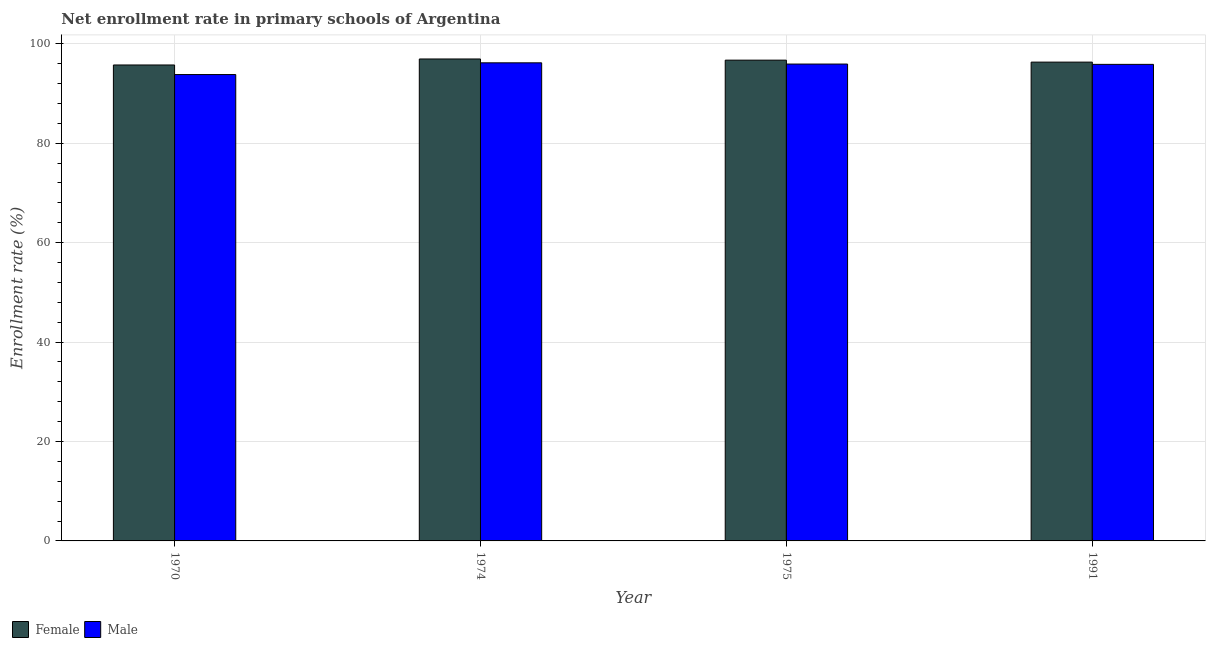How many different coloured bars are there?
Your answer should be compact. 2. Are the number of bars on each tick of the X-axis equal?
Provide a short and direct response. Yes. How many bars are there on the 1st tick from the left?
Provide a succinct answer. 2. In how many cases, is the number of bars for a given year not equal to the number of legend labels?
Your response must be concise. 0. What is the enrollment rate of male students in 1974?
Give a very brief answer. 96.17. Across all years, what is the maximum enrollment rate of female students?
Offer a terse response. 96.94. Across all years, what is the minimum enrollment rate of male students?
Ensure brevity in your answer.  93.81. In which year was the enrollment rate of female students maximum?
Provide a succinct answer. 1974. In which year was the enrollment rate of female students minimum?
Provide a short and direct response. 1970. What is the total enrollment rate of male students in the graph?
Provide a succinct answer. 381.76. What is the difference between the enrollment rate of female students in 1970 and that in 1974?
Make the answer very short. -1.21. What is the difference between the enrollment rate of female students in 1991 and the enrollment rate of male students in 1970?
Provide a succinct answer. 0.57. What is the average enrollment rate of female students per year?
Ensure brevity in your answer.  96.42. In how many years, is the enrollment rate of female students greater than 44 %?
Offer a very short reply. 4. What is the ratio of the enrollment rate of male students in 1970 to that in 1975?
Ensure brevity in your answer.  0.98. What is the difference between the highest and the second highest enrollment rate of male students?
Ensure brevity in your answer.  0.25. What is the difference between the highest and the lowest enrollment rate of female students?
Offer a terse response. 1.21. Is the sum of the enrollment rate of female students in 1975 and 1991 greater than the maximum enrollment rate of male students across all years?
Provide a short and direct response. Yes. What does the 2nd bar from the left in 1974 represents?
Your response must be concise. Male. Are all the bars in the graph horizontal?
Your answer should be very brief. No. Does the graph contain any zero values?
Make the answer very short. No. How many legend labels are there?
Provide a short and direct response. 2. What is the title of the graph?
Offer a very short reply. Net enrollment rate in primary schools of Argentina. What is the label or title of the Y-axis?
Your answer should be compact. Enrollment rate (%). What is the Enrollment rate (%) of Female in 1970?
Your answer should be compact. 95.74. What is the Enrollment rate (%) of Male in 1970?
Keep it short and to the point. 93.81. What is the Enrollment rate (%) in Female in 1974?
Provide a succinct answer. 96.94. What is the Enrollment rate (%) in Male in 1974?
Your answer should be very brief. 96.17. What is the Enrollment rate (%) of Female in 1975?
Your answer should be compact. 96.71. What is the Enrollment rate (%) of Male in 1975?
Give a very brief answer. 95.92. What is the Enrollment rate (%) of Female in 1991?
Offer a very short reply. 96.31. What is the Enrollment rate (%) in Male in 1991?
Make the answer very short. 95.86. Across all years, what is the maximum Enrollment rate (%) of Female?
Make the answer very short. 96.94. Across all years, what is the maximum Enrollment rate (%) of Male?
Your response must be concise. 96.17. Across all years, what is the minimum Enrollment rate (%) in Female?
Give a very brief answer. 95.74. Across all years, what is the minimum Enrollment rate (%) of Male?
Make the answer very short. 93.81. What is the total Enrollment rate (%) of Female in the graph?
Your response must be concise. 385.7. What is the total Enrollment rate (%) in Male in the graph?
Offer a terse response. 381.76. What is the difference between the Enrollment rate (%) in Female in 1970 and that in 1974?
Provide a succinct answer. -1.21. What is the difference between the Enrollment rate (%) in Male in 1970 and that in 1974?
Offer a very short reply. -2.36. What is the difference between the Enrollment rate (%) of Female in 1970 and that in 1975?
Your answer should be very brief. -0.97. What is the difference between the Enrollment rate (%) of Male in 1970 and that in 1975?
Your answer should be very brief. -2.11. What is the difference between the Enrollment rate (%) in Female in 1970 and that in 1991?
Offer a terse response. -0.57. What is the difference between the Enrollment rate (%) in Male in 1970 and that in 1991?
Ensure brevity in your answer.  -2.05. What is the difference between the Enrollment rate (%) of Female in 1974 and that in 1975?
Ensure brevity in your answer.  0.24. What is the difference between the Enrollment rate (%) of Male in 1974 and that in 1975?
Your response must be concise. 0.25. What is the difference between the Enrollment rate (%) of Female in 1974 and that in 1991?
Offer a very short reply. 0.63. What is the difference between the Enrollment rate (%) of Male in 1974 and that in 1991?
Give a very brief answer. 0.31. What is the difference between the Enrollment rate (%) of Female in 1975 and that in 1991?
Your answer should be very brief. 0.4. What is the difference between the Enrollment rate (%) of Male in 1975 and that in 1991?
Provide a succinct answer. 0.07. What is the difference between the Enrollment rate (%) in Female in 1970 and the Enrollment rate (%) in Male in 1974?
Ensure brevity in your answer.  -0.43. What is the difference between the Enrollment rate (%) of Female in 1970 and the Enrollment rate (%) of Male in 1975?
Make the answer very short. -0.19. What is the difference between the Enrollment rate (%) of Female in 1970 and the Enrollment rate (%) of Male in 1991?
Make the answer very short. -0.12. What is the difference between the Enrollment rate (%) of Female in 1974 and the Enrollment rate (%) of Male in 1975?
Provide a succinct answer. 1.02. What is the difference between the Enrollment rate (%) in Female in 1974 and the Enrollment rate (%) in Male in 1991?
Your response must be concise. 1.09. What is the difference between the Enrollment rate (%) of Female in 1975 and the Enrollment rate (%) of Male in 1991?
Provide a short and direct response. 0.85. What is the average Enrollment rate (%) in Female per year?
Keep it short and to the point. 96.42. What is the average Enrollment rate (%) in Male per year?
Your answer should be very brief. 95.44. In the year 1970, what is the difference between the Enrollment rate (%) of Female and Enrollment rate (%) of Male?
Provide a succinct answer. 1.93. In the year 1974, what is the difference between the Enrollment rate (%) of Female and Enrollment rate (%) of Male?
Provide a short and direct response. 0.77. In the year 1975, what is the difference between the Enrollment rate (%) of Female and Enrollment rate (%) of Male?
Provide a succinct answer. 0.78. In the year 1991, what is the difference between the Enrollment rate (%) in Female and Enrollment rate (%) in Male?
Keep it short and to the point. 0.45. What is the ratio of the Enrollment rate (%) of Female in 1970 to that in 1974?
Keep it short and to the point. 0.99. What is the ratio of the Enrollment rate (%) of Male in 1970 to that in 1974?
Provide a succinct answer. 0.98. What is the ratio of the Enrollment rate (%) of Female in 1970 to that in 1975?
Your answer should be compact. 0.99. What is the ratio of the Enrollment rate (%) of Male in 1970 to that in 1975?
Your answer should be compact. 0.98. What is the ratio of the Enrollment rate (%) in Female in 1970 to that in 1991?
Offer a terse response. 0.99. What is the ratio of the Enrollment rate (%) in Male in 1970 to that in 1991?
Your response must be concise. 0.98. What is the ratio of the Enrollment rate (%) in Female in 1974 to that in 1991?
Make the answer very short. 1.01. What is the ratio of the Enrollment rate (%) of Male in 1974 to that in 1991?
Make the answer very short. 1. What is the ratio of the Enrollment rate (%) of Female in 1975 to that in 1991?
Make the answer very short. 1. What is the difference between the highest and the second highest Enrollment rate (%) of Female?
Provide a succinct answer. 0.24. What is the difference between the highest and the second highest Enrollment rate (%) of Male?
Make the answer very short. 0.25. What is the difference between the highest and the lowest Enrollment rate (%) of Female?
Your answer should be compact. 1.21. What is the difference between the highest and the lowest Enrollment rate (%) in Male?
Keep it short and to the point. 2.36. 